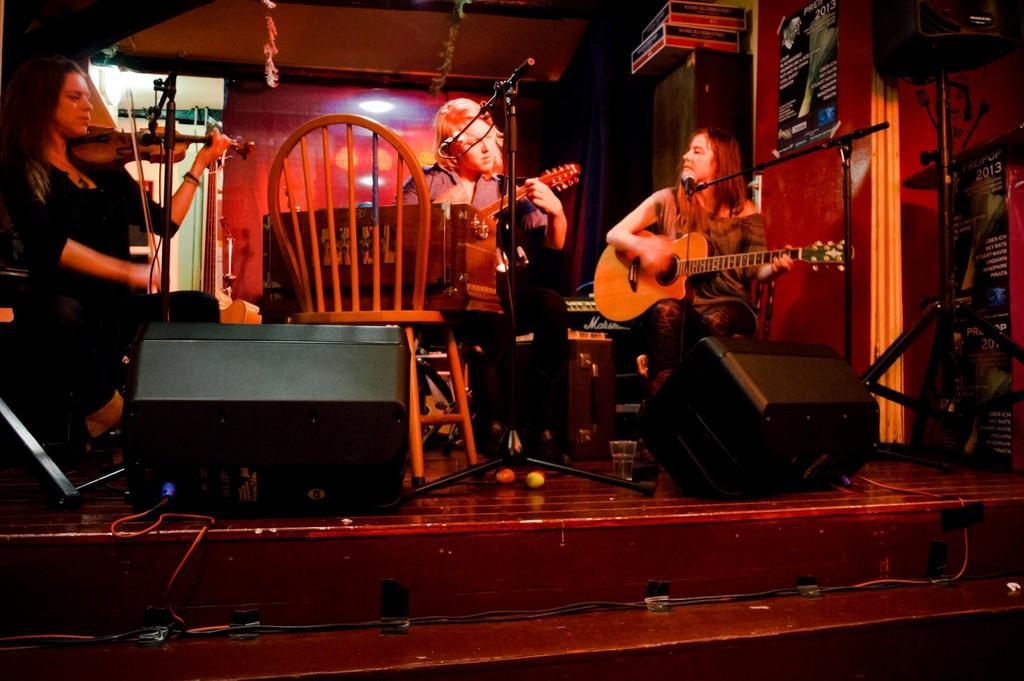In one or two sentences, can you explain what this image depicts? The image consists of three women who are playing the guitar,violin. There is a mic in front of the woman who is sitting in the middle. To the left side there is a woman who is playing the violin. To the right side there is a woman who is playing the guitar and singing through the mic. At the background there is a wall. At the bottom there is speakers,balls and stand. 